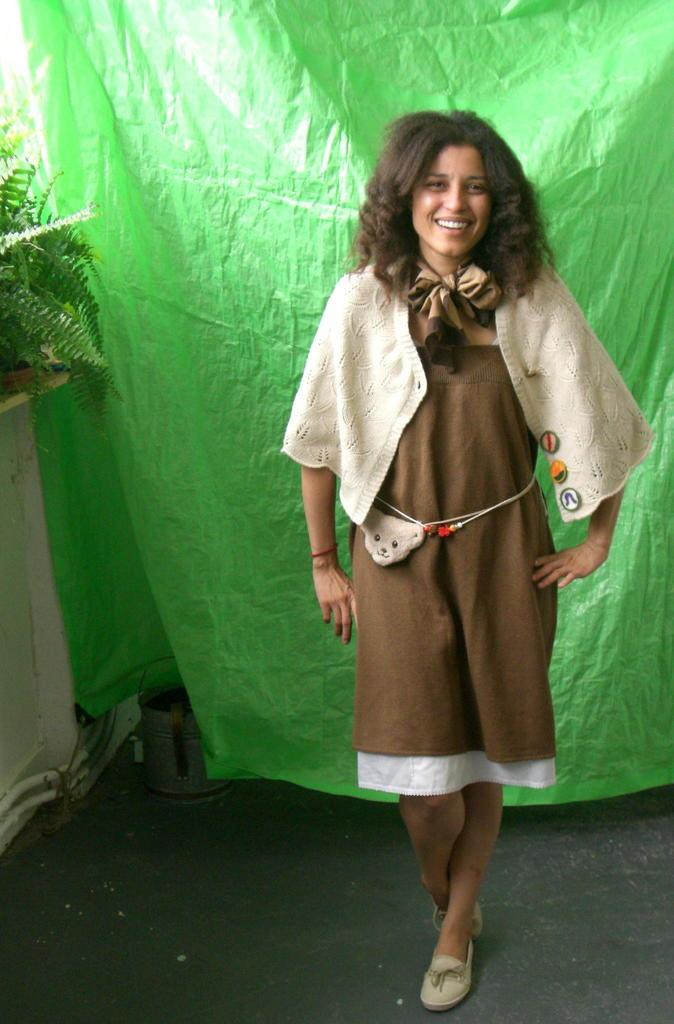What is the woman doing in the image? The woman is standing in the image. What is covering the woman's back? The woman has a cover on her back. What is located next to the woman? There is a plant next to the woman. What is the woman's facial expression? The woman is smiling. What other object can be seen in the image? There is a bucket in the image. What is the woman's brother doing in the image? There is no mention of a brother in the image, so we cannot answer this question. 